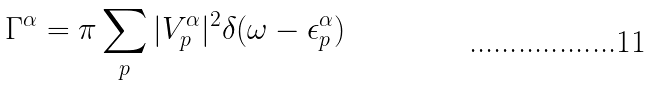<formula> <loc_0><loc_0><loc_500><loc_500>\Gamma ^ { \alpha } = \pi \sum _ { p } | V _ { p } ^ { \alpha } | ^ { 2 } \delta ( \omega - \epsilon _ { p } ^ { \alpha } )</formula> 